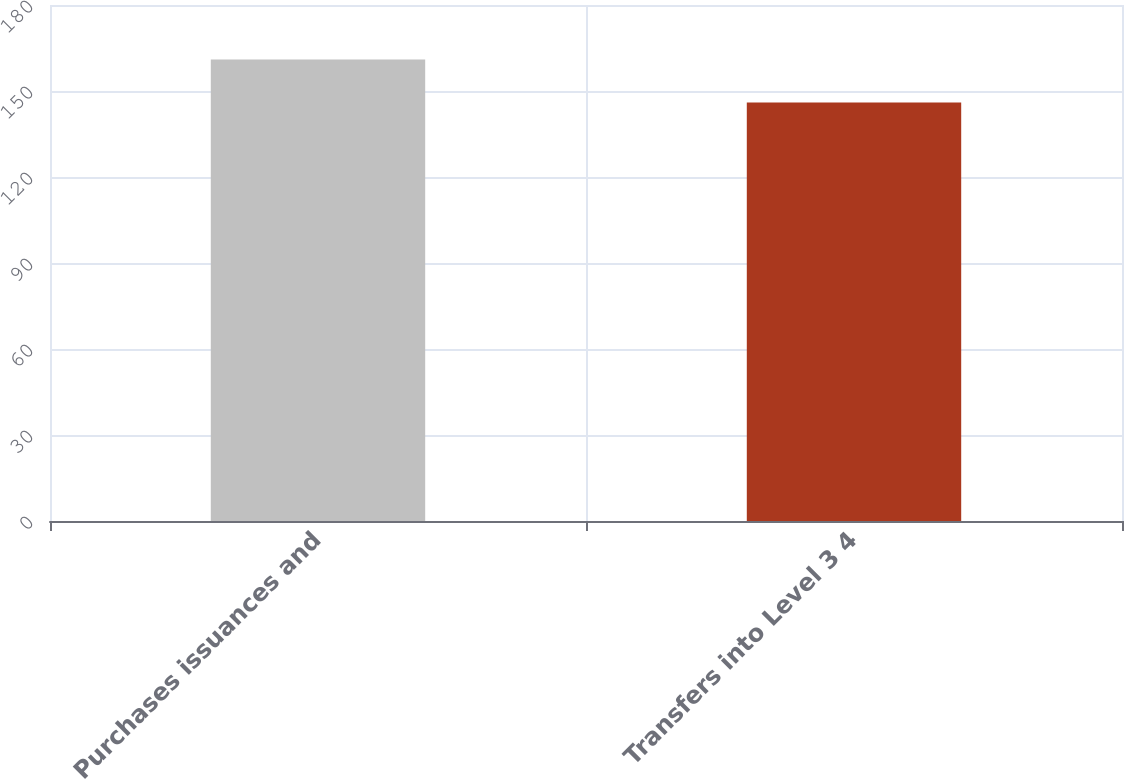Convert chart. <chart><loc_0><loc_0><loc_500><loc_500><bar_chart><fcel>Purchases issuances and<fcel>Transfers into Level 3 4<nl><fcel>161<fcel>146<nl></chart> 